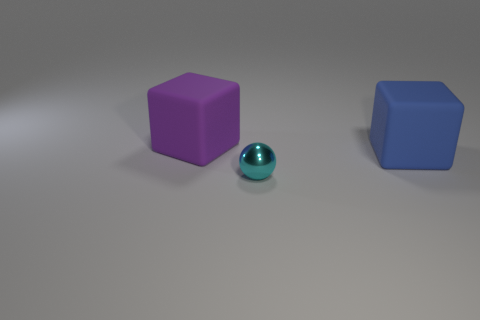Add 3 small red things. How many objects exist? 6 Subtract all blocks. How many objects are left? 1 Add 3 matte objects. How many matte objects are left? 5 Add 2 blue rubber cubes. How many blue rubber cubes exist? 3 Subtract 0 green blocks. How many objects are left? 3 Subtract all large yellow rubber cylinders. Subtract all large purple matte things. How many objects are left? 2 